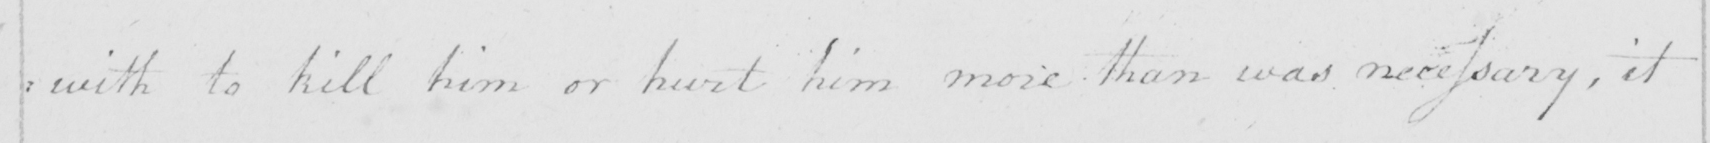What does this handwritten line say? :with to kill him or hurt him more than was necessary, it 